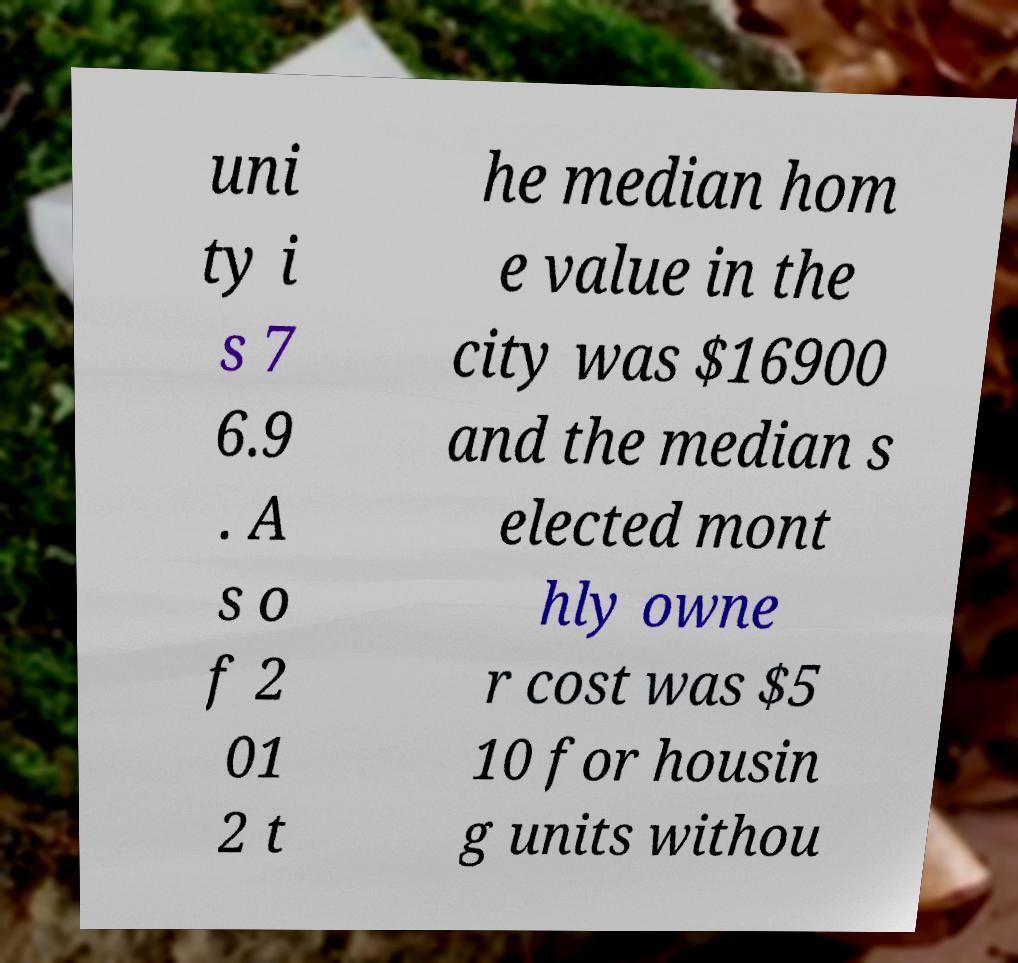What messages or text are displayed in this image? I need them in a readable, typed format. uni ty i s 7 6.9 . A s o f 2 01 2 t he median hom e value in the city was $16900 and the median s elected mont hly owne r cost was $5 10 for housin g units withou 